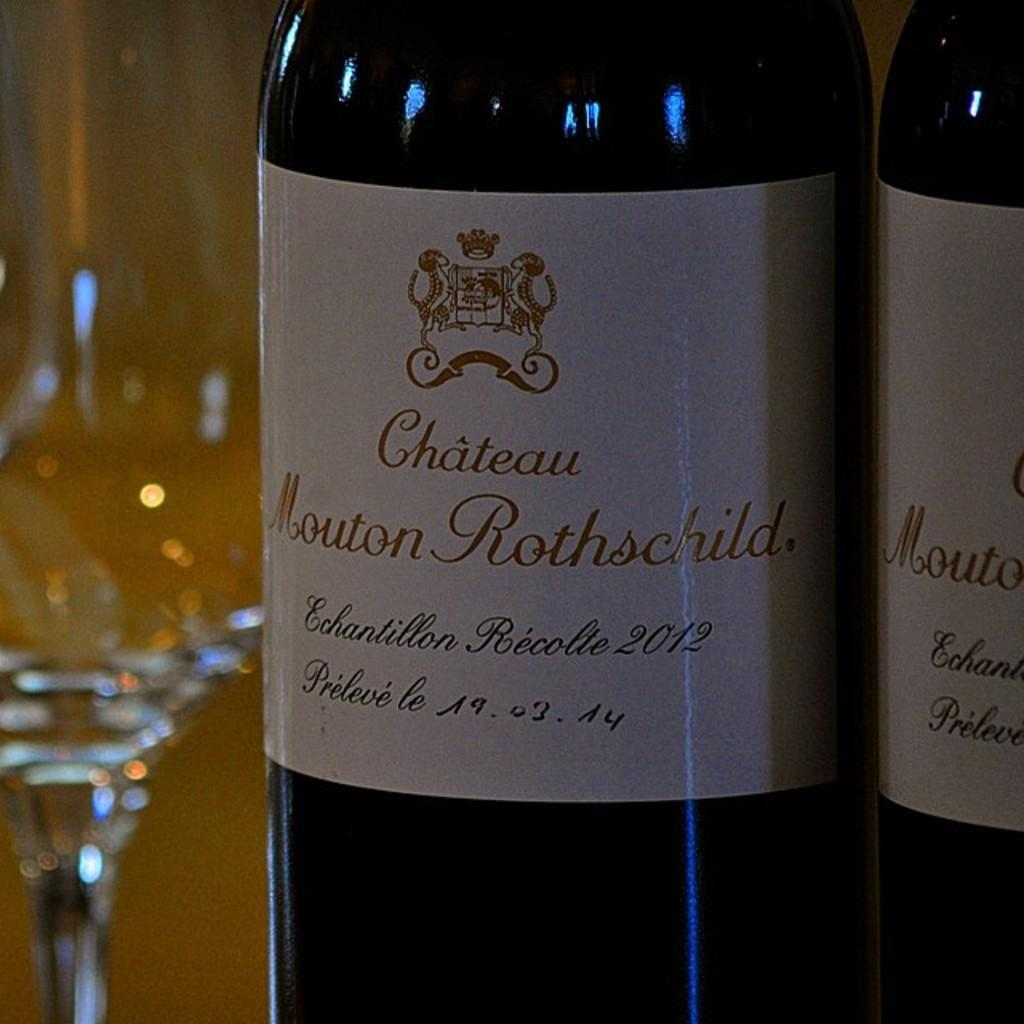<image>
Describe the image concisely. Two bottles of Chateau Mouton Rothschild wine are near empty wine glasses. 